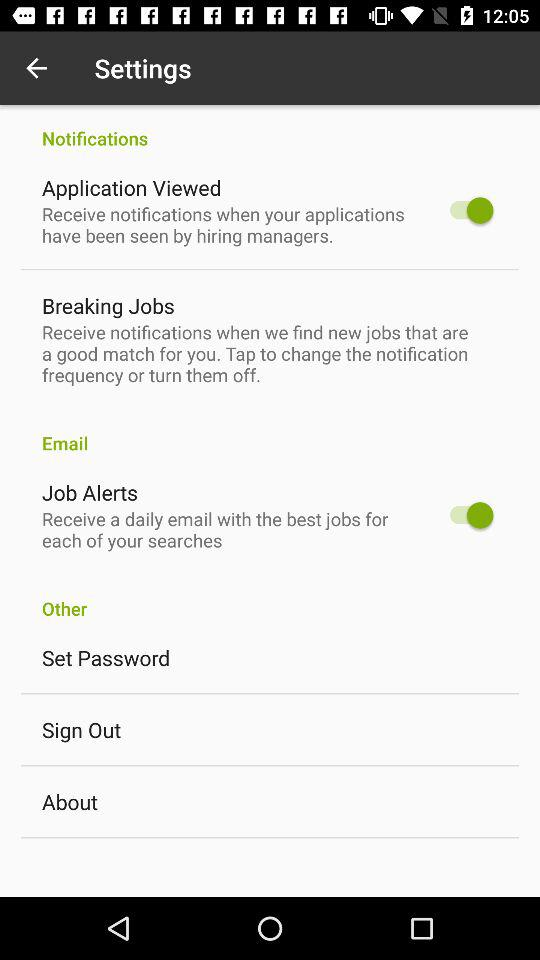What is the status of the "Application Viewed"? The status is "on". 